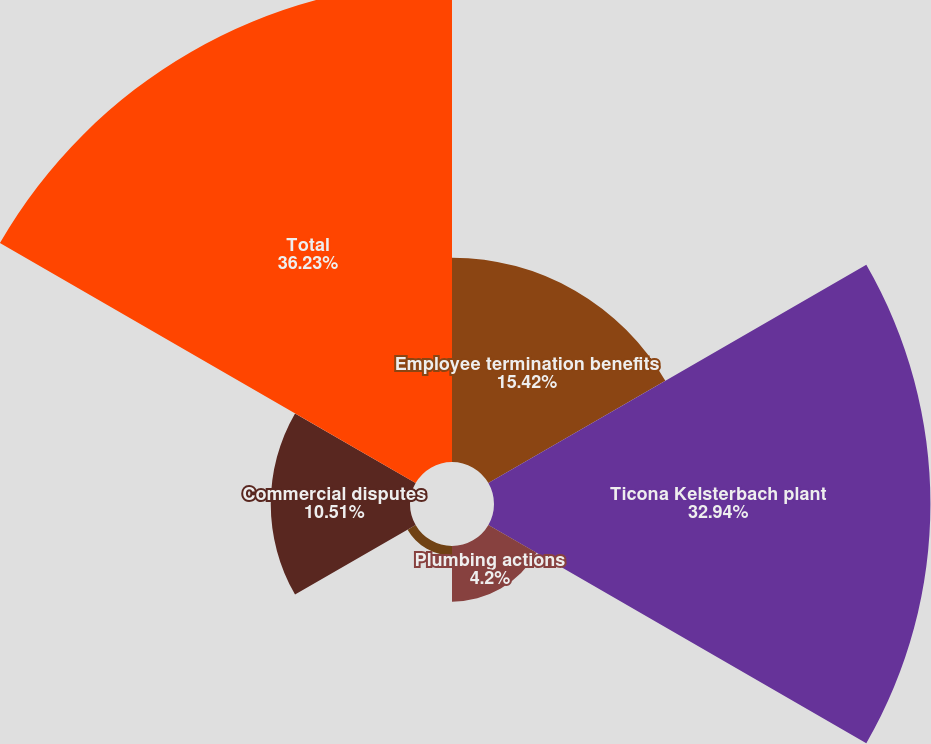Convert chart to OTSL. <chart><loc_0><loc_0><loc_500><loc_500><pie_chart><fcel>Employee termination benefits<fcel>Ticona Kelsterbach plant<fcel>Plumbing actions<fcel>Asset impairments<fcel>Commercial disputes<fcel>Total<nl><fcel>15.42%<fcel>32.94%<fcel>4.2%<fcel>0.7%<fcel>10.51%<fcel>36.23%<nl></chart> 